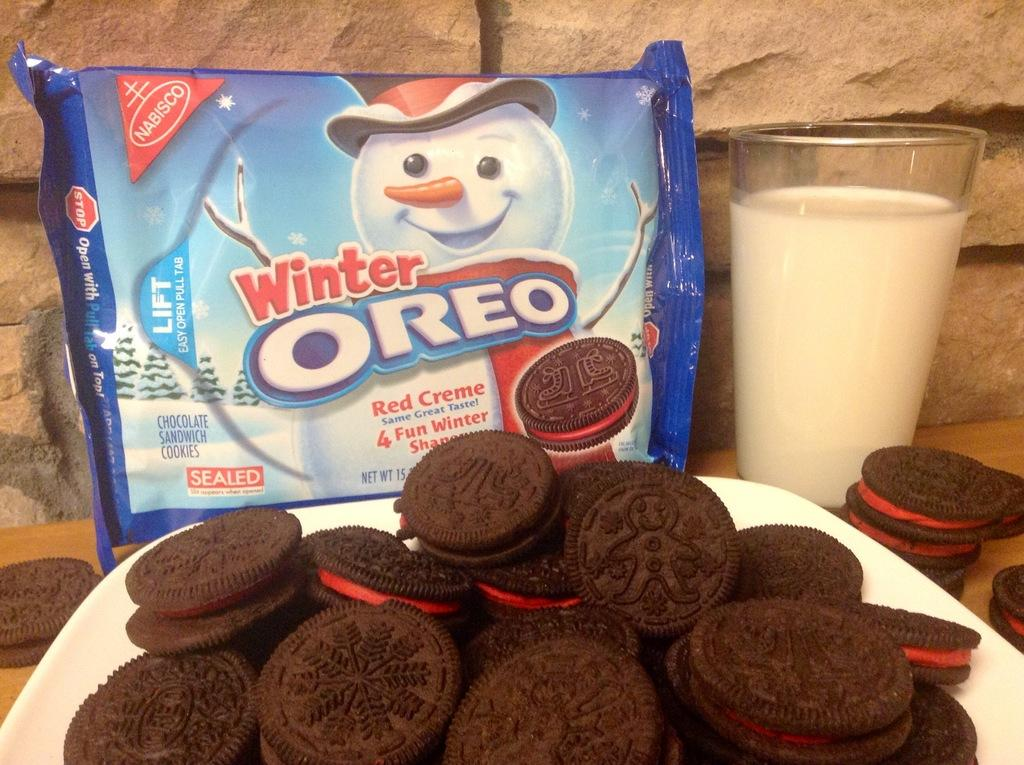What type of food is on the plate in the image? There are cookies on the plate in the image. What beverage is visible in the image? There is a glass of milk in the image. What else related to cookies can be seen in the image? There is a cookies packet in the image. Are there any cookies outside of the plate in the image? Yes, there are cookies on the table in the image. What can be seen in the background of the image? There is a stone wall in the background of the image. What type of government is depicted in the image? There is no depiction of a government in the image; it features cookies, milk, and a stone wall. How many planes are visible in the image? There are no planes present in the image. 